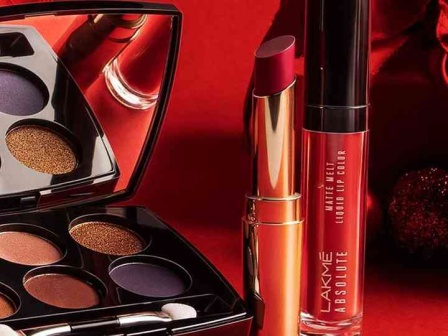What does the general color scheme tell you about the mood of the image? The color scheme of the image features intense and bold hues such as red, purple, and gold, which collectively convey a sense of luxury, sophistication, and excitement. Red background sets a passionate and dynamic mood, while the gold accents introduce a touch of opulence. The dark purple shades add a layer of elegance and depth, suggesting that the makeup products are designed for creating striking and glamorous looks suitable for special occasions or evening wear. 